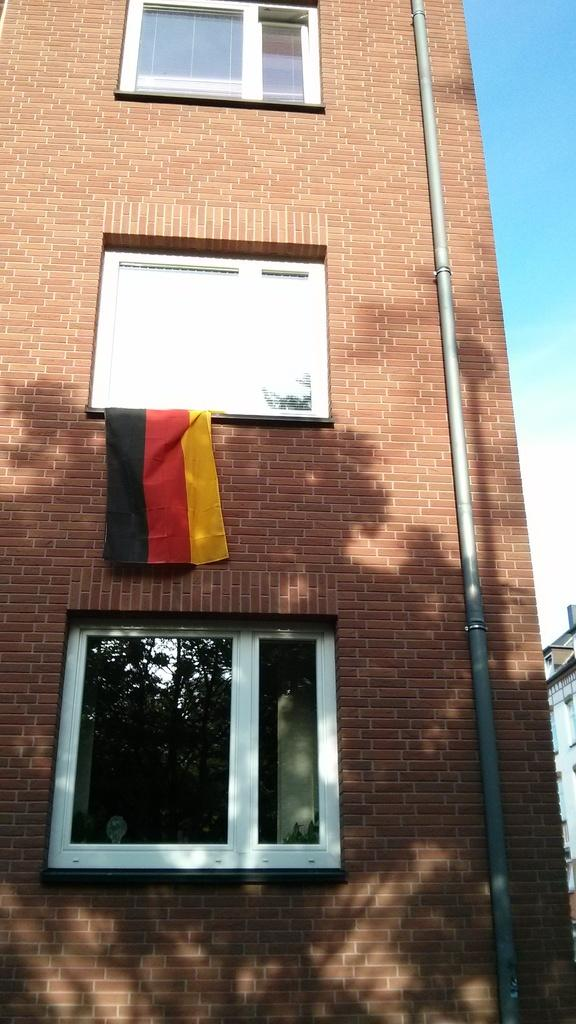What type of structure is in the image? There is a building in the image. What feature can be seen on the building? The building has windows. Is there any additional detail on the building? Yes, there is a pipe on the wall of the building. What is present at the middle window? A cloth is present at the middle window. What can be seen on the right side of the image? There is another building on the right side of the image. What is visible in the sky? Clouds are visible in the sky. What type of scissors can be seen in the image? There are no scissors present in the image. Who is the partner of the person standing next to the building in the image? There is no person standing next to the building in the image. Is there a gun visible in the image? There is no gun present in the image. 